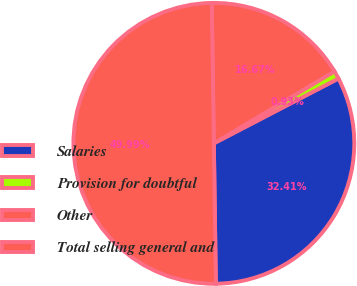<chart> <loc_0><loc_0><loc_500><loc_500><pie_chart><fcel>Salaries<fcel>Provision for doubtful<fcel>Other<fcel>Total selling general and<nl><fcel>32.41%<fcel>0.93%<fcel>16.67%<fcel>50.0%<nl></chart> 